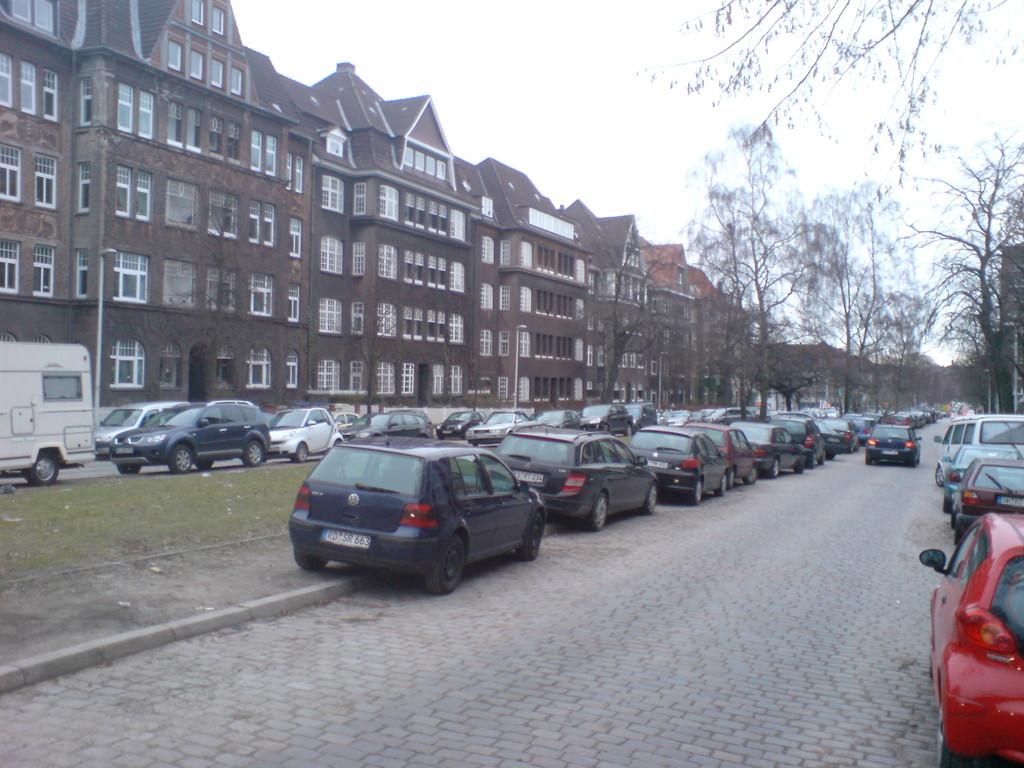What type of structures can be seen in the image? There are buildings in the image. What is the color of the buildings? The buildings are brown in color. What other elements are present in the image besides the buildings? There are trees and vehicles in the image. Can you describe the grip of the trees in the image? There is no mention of the grip of the trees in the image, as the focus is on their presence and not their physical characteristics. 